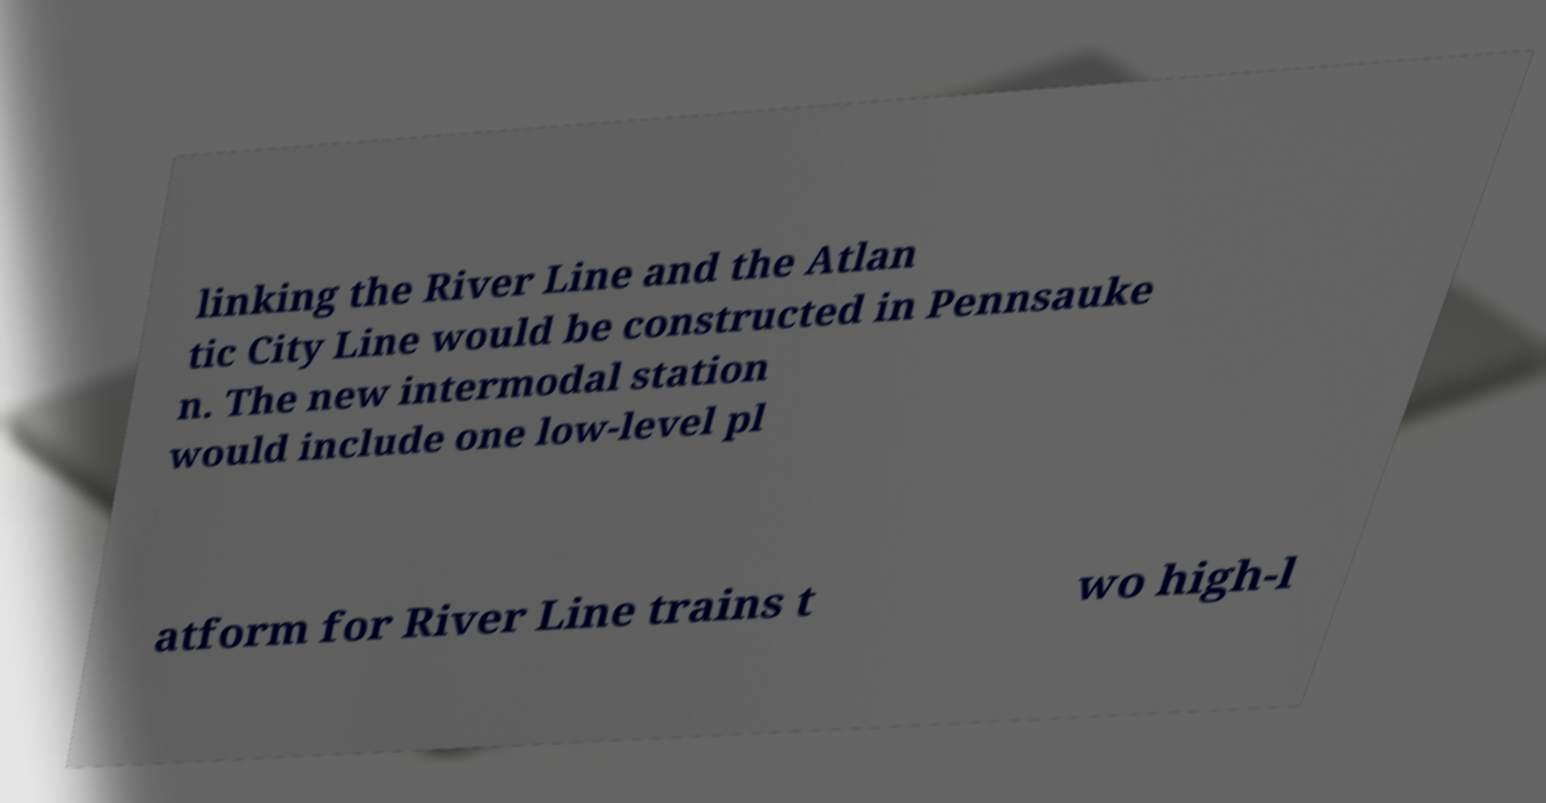Could you assist in decoding the text presented in this image and type it out clearly? linking the River Line and the Atlan tic City Line would be constructed in Pennsauke n. The new intermodal station would include one low-level pl atform for River Line trains t wo high-l 